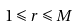Convert formula to latex. <formula><loc_0><loc_0><loc_500><loc_500>1 \leqslant r \leqslant M</formula> 